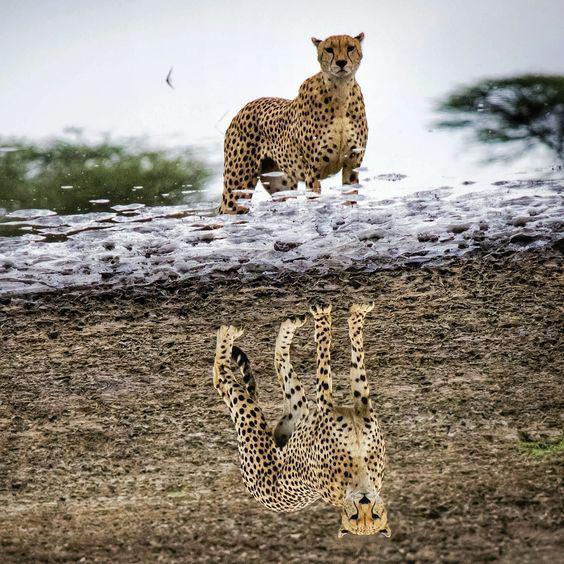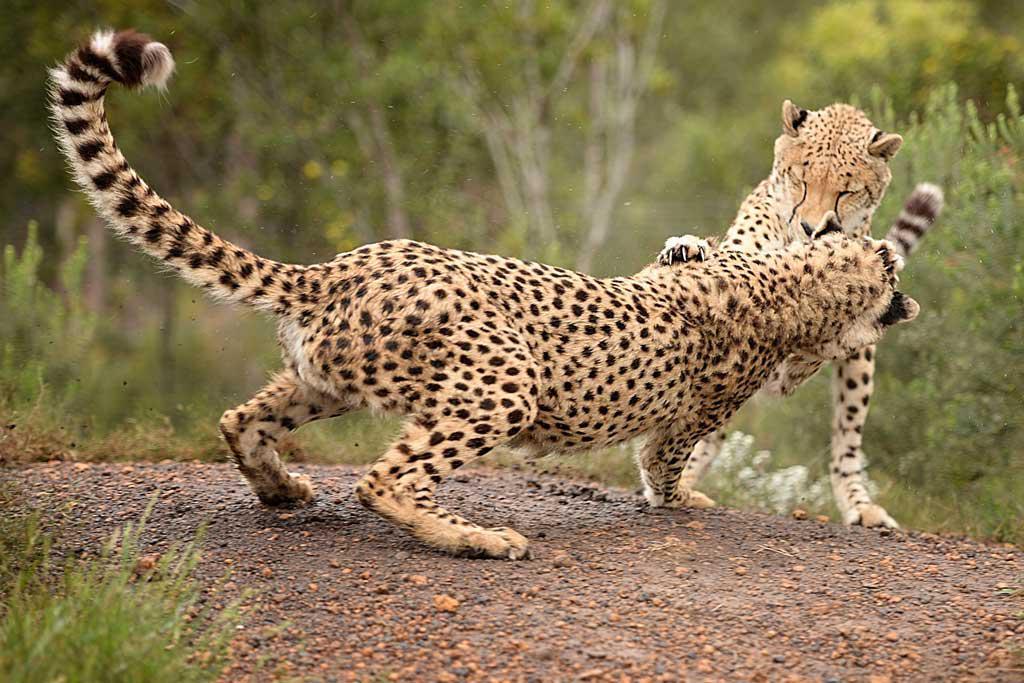The first image is the image on the left, the second image is the image on the right. Given the left and right images, does the statement "There are 5 or more cheetahs." hold true? Answer yes or no. No. The first image is the image on the left, the second image is the image on the right. Assess this claim about the two images: "There are at least two leopards laying down on their sides together in one of the images.". Correct or not? Answer yes or no. No. 